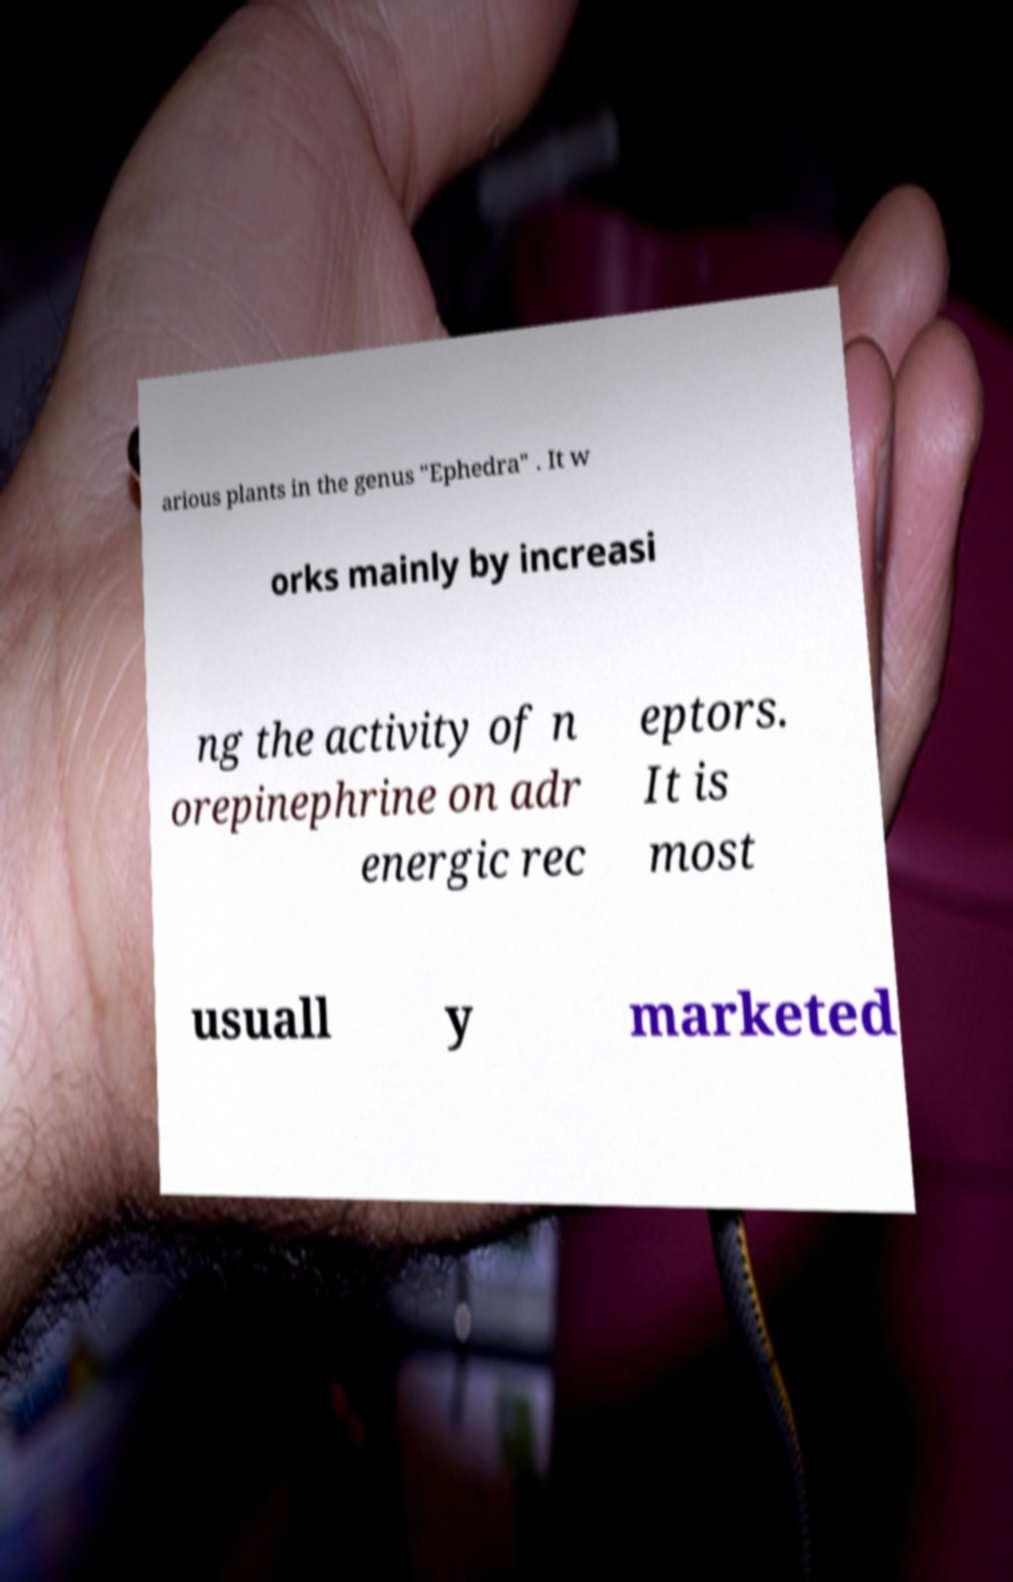Could you assist in decoding the text presented in this image and type it out clearly? arious plants in the genus "Ephedra" . It w orks mainly by increasi ng the activity of n orepinephrine on adr energic rec eptors. It is most usuall y marketed 